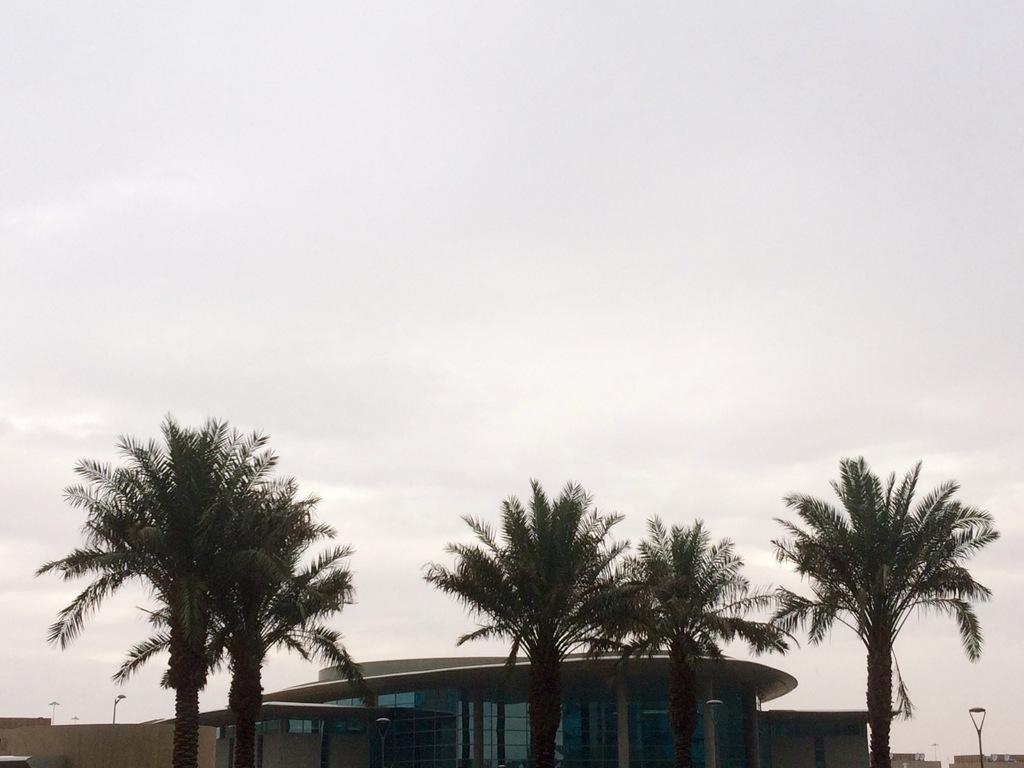What type of vegetation is present in the image? There are trees in the image. What is the color of the trees? The trees are green in color. What can be seen in the background of the image? There is a building in the background of the image. What is the color of the building? The building is cream in color. What part of the natural environment is visible in the image? The sky is visible in the image. What is the color of the sky? The sky is white in color. What type of advice can be seen being given in the image? There is no indication of advice being given in the image; it features trees, a building, and the sky. How many passengers are visible in the image? There are no passengers present in the image. 